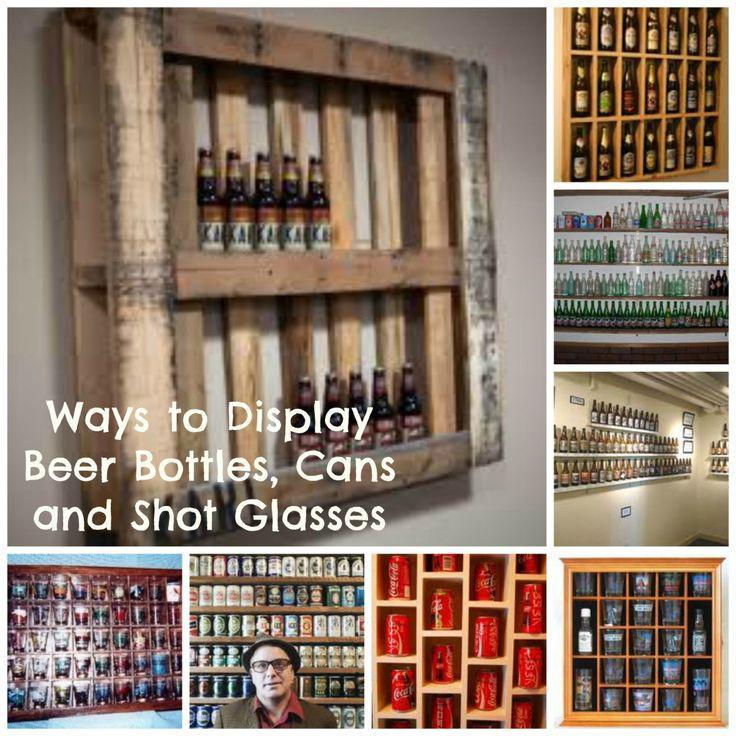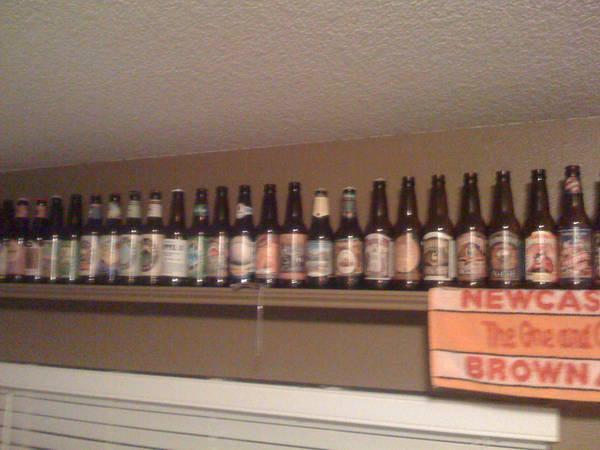The first image is the image on the left, the second image is the image on the right. Evaluate the accuracy of this statement regarding the images: "An image shows only one shelf with at least 13 bottles lined in a row.". Is it true? Answer yes or no. Yes. 